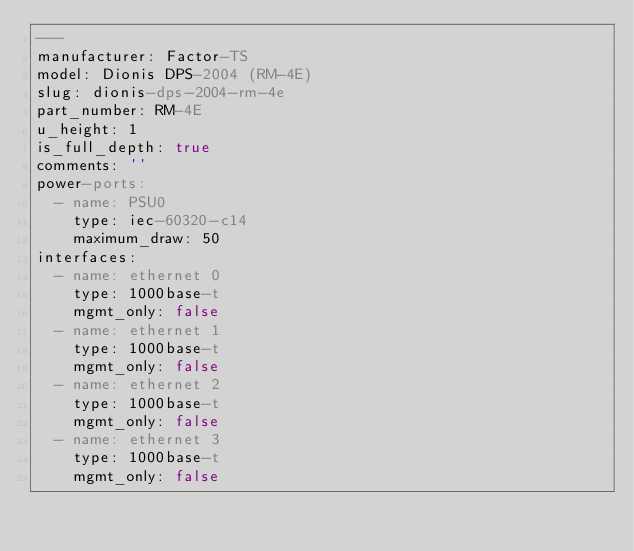Convert code to text. <code><loc_0><loc_0><loc_500><loc_500><_YAML_>---
manufacturer: Factor-TS
model: Dionis DPS-2004 (RM-4E)
slug: dionis-dps-2004-rm-4e
part_number: RM-4E
u_height: 1
is_full_depth: true
comments: ''
power-ports:
  - name: PSU0
    type: iec-60320-c14
    maximum_draw: 50
interfaces:
  - name: ethernet 0
    type: 1000base-t
    mgmt_only: false
  - name: ethernet 1
    type: 1000base-t
    mgmt_only: false
  - name: ethernet 2
    type: 1000base-t
    mgmt_only: false
  - name: ethernet 3
    type: 1000base-t
    mgmt_only: false
</code> 